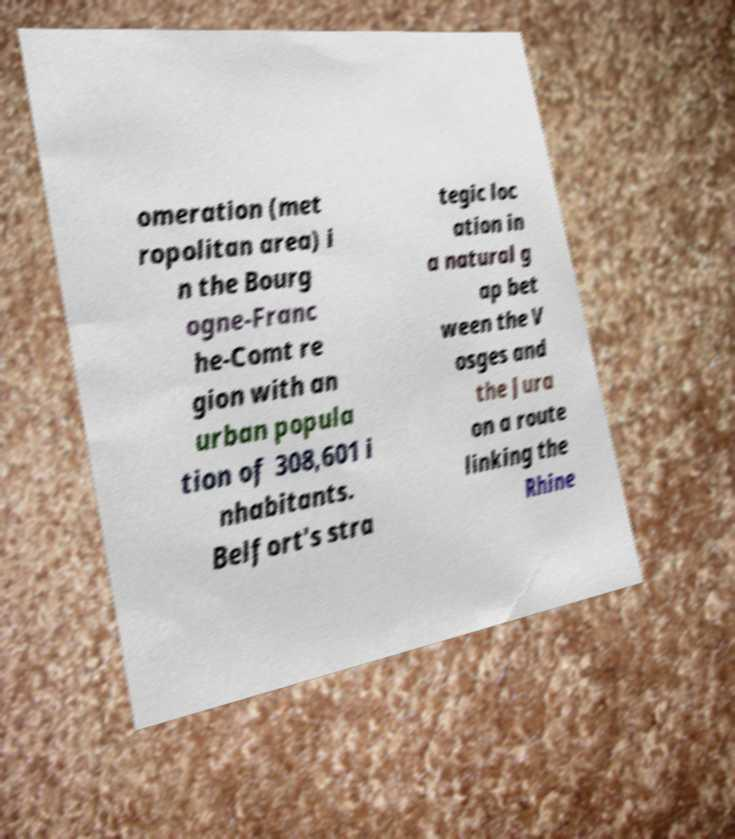For documentation purposes, I need the text within this image transcribed. Could you provide that? omeration (met ropolitan area) i n the Bourg ogne-Franc he-Comt re gion with an urban popula tion of 308,601 i nhabitants. Belfort's stra tegic loc ation in a natural g ap bet ween the V osges and the Jura on a route linking the Rhine 